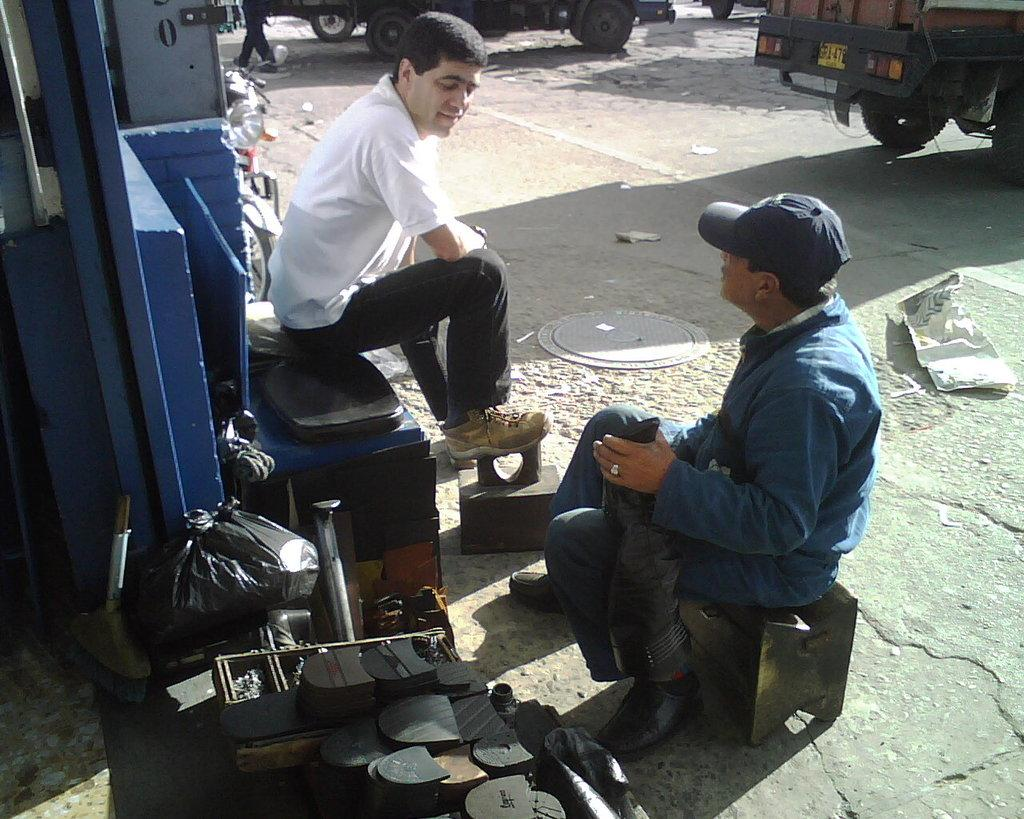How many people are sitting in the image? There are two persons sitting in the image. What can be seen in the background of the image? Vehicles are visible in the background of the image. What is located at the bottom of the image? There are products at the bottom of the image. Are there any boats visible in the image? No, there are no boats present in the image. Can you see a kiss happening between the two persons in the image? No, the image does not depict a kiss between the two persons or any other kiss. 